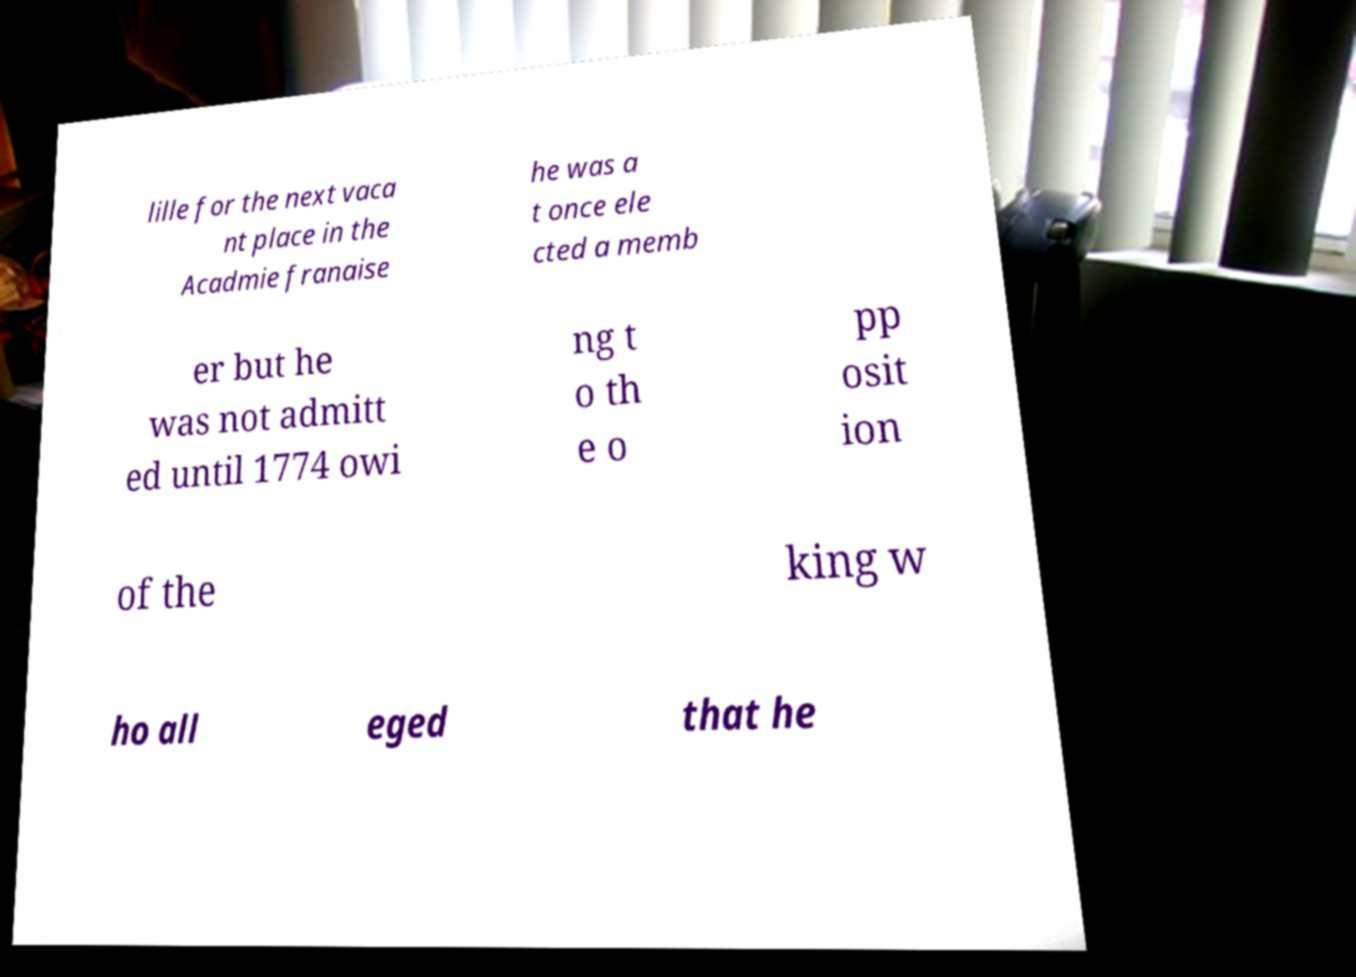Can you accurately transcribe the text from the provided image for me? lille for the next vaca nt place in the Acadmie franaise he was a t once ele cted a memb er but he was not admitt ed until 1774 owi ng t o th e o pp osit ion of the king w ho all eged that he 